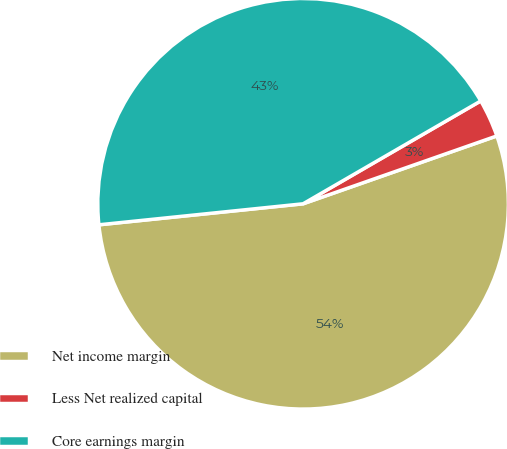Convert chart. <chart><loc_0><loc_0><loc_500><loc_500><pie_chart><fcel>Net income margin<fcel>Less Net realized capital<fcel>Core earnings margin<nl><fcel>53.73%<fcel>2.99%<fcel>43.28%<nl></chart> 